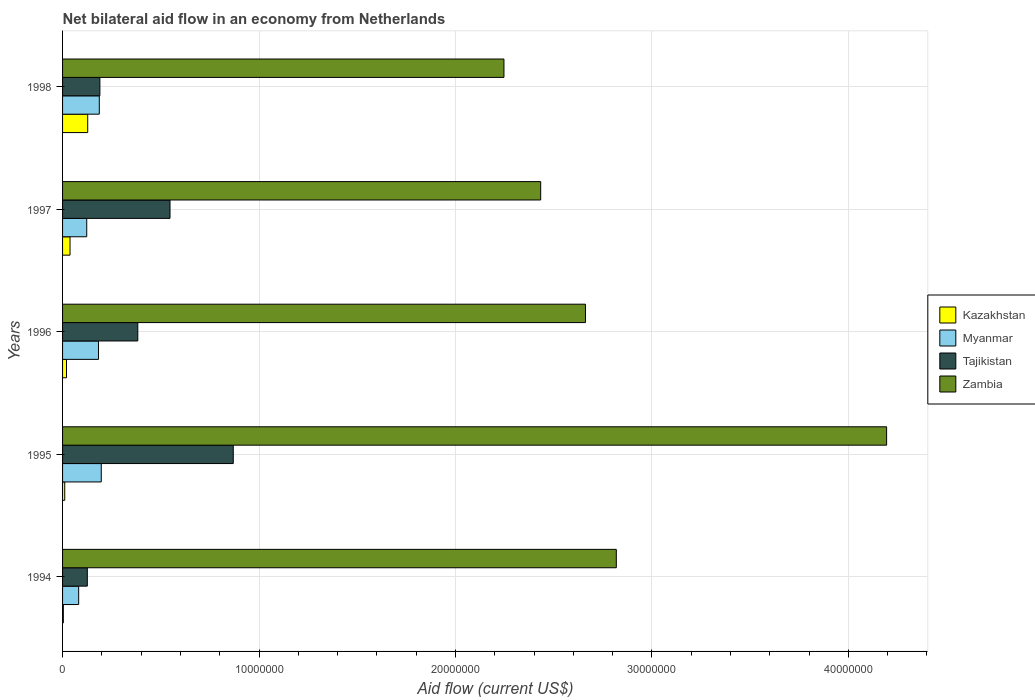How many different coloured bars are there?
Your response must be concise. 4. Are the number of bars on each tick of the Y-axis equal?
Ensure brevity in your answer.  Yes. How many bars are there on the 3rd tick from the top?
Provide a succinct answer. 4. What is the label of the 3rd group of bars from the top?
Your response must be concise. 1996. What is the net bilateral aid flow in Zambia in 1994?
Your response must be concise. 2.82e+07. Across all years, what is the maximum net bilateral aid flow in Myanmar?
Your response must be concise. 1.97e+06. Across all years, what is the minimum net bilateral aid flow in Myanmar?
Your answer should be very brief. 8.20e+05. In which year was the net bilateral aid flow in Myanmar maximum?
Provide a succinct answer. 1995. What is the total net bilateral aid flow in Kazakhstan in the graph?
Provide a short and direct response. 2.01e+06. What is the difference between the net bilateral aid flow in Myanmar in 1996 and that in 1998?
Provide a short and direct response. -4.00e+04. What is the average net bilateral aid flow in Zambia per year?
Your response must be concise. 2.87e+07. In the year 1996, what is the difference between the net bilateral aid flow in Zambia and net bilateral aid flow in Myanmar?
Keep it short and to the point. 2.48e+07. What is the ratio of the net bilateral aid flow in Myanmar in 1994 to that in 1998?
Give a very brief answer. 0.44. Is the net bilateral aid flow in Zambia in 1994 less than that in 1995?
Offer a terse response. Yes. Is the difference between the net bilateral aid flow in Zambia in 1994 and 1998 greater than the difference between the net bilateral aid flow in Myanmar in 1994 and 1998?
Offer a very short reply. Yes. What is the difference between the highest and the second highest net bilateral aid flow in Myanmar?
Provide a succinct answer. 1.00e+05. What is the difference between the highest and the lowest net bilateral aid flow in Myanmar?
Ensure brevity in your answer.  1.15e+06. Is the sum of the net bilateral aid flow in Zambia in 1995 and 1996 greater than the maximum net bilateral aid flow in Kazakhstan across all years?
Offer a terse response. Yes. What does the 3rd bar from the top in 1998 represents?
Ensure brevity in your answer.  Myanmar. What does the 4th bar from the bottom in 1997 represents?
Your answer should be very brief. Zambia. How many years are there in the graph?
Keep it short and to the point. 5. What is the difference between two consecutive major ticks on the X-axis?
Offer a terse response. 1.00e+07. Are the values on the major ticks of X-axis written in scientific E-notation?
Your answer should be compact. No. Does the graph contain grids?
Make the answer very short. Yes. Where does the legend appear in the graph?
Make the answer very short. Center right. How many legend labels are there?
Make the answer very short. 4. How are the legend labels stacked?
Provide a short and direct response. Vertical. What is the title of the graph?
Provide a short and direct response. Net bilateral aid flow in an economy from Netherlands. What is the Aid flow (current US$) in Kazakhstan in 1994?
Your response must be concise. 4.00e+04. What is the Aid flow (current US$) of Myanmar in 1994?
Provide a short and direct response. 8.20e+05. What is the Aid flow (current US$) of Tajikistan in 1994?
Your answer should be very brief. 1.26e+06. What is the Aid flow (current US$) of Zambia in 1994?
Offer a very short reply. 2.82e+07. What is the Aid flow (current US$) of Myanmar in 1995?
Offer a very short reply. 1.97e+06. What is the Aid flow (current US$) in Tajikistan in 1995?
Offer a terse response. 8.69e+06. What is the Aid flow (current US$) of Zambia in 1995?
Make the answer very short. 4.20e+07. What is the Aid flow (current US$) of Myanmar in 1996?
Provide a succinct answer. 1.83e+06. What is the Aid flow (current US$) of Tajikistan in 1996?
Your answer should be very brief. 3.83e+06. What is the Aid flow (current US$) of Zambia in 1996?
Your answer should be very brief. 2.66e+07. What is the Aid flow (current US$) of Myanmar in 1997?
Provide a short and direct response. 1.23e+06. What is the Aid flow (current US$) of Tajikistan in 1997?
Ensure brevity in your answer.  5.47e+06. What is the Aid flow (current US$) in Zambia in 1997?
Offer a very short reply. 2.43e+07. What is the Aid flow (current US$) in Kazakhstan in 1998?
Provide a succinct answer. 1.28e+06. What is the Aid flow (current US$) in Myanmar in 1998?
Give a very brief answer. 1.87e+06. What is the Aid flow (current US$) of Tajikistan in 1998?
Your answer should be compact. 1.90e+06. What is the Aid flow (current US$) of Zambia in 1998?
Make the answer very short. 2.25e+07. Across all years, what is the maximum Aid flow (current US$) of Kazakhstan?
Your answer should be compact. 1.28e+06. Across all years, what is the maximum Aid flow (current US$) in Myanmar?
Offer a terse response. 1.97e+06. Across all years, what is the maximum Aid flow (current US$) of Tajikistan?
Your response must be concise. 8.69e+06. Across all years, what is the maximum Aid flow (current US$) in Zambia?
Offer a very short reply. 4.20e+07. Across all years, what is the minimum Aid flow (current US$) of Myanmar?
Your answer should be compact. 8.20e+05. Across all years, what is the minimum Aid flow (current US$) of Tajikistan?
Offer a terse response. 1.26e+06. Across all years, what is the minimum Aid flow (current US$) in Zambia?
Ensure brevity in your answer.  2.25e+07. What is the total Aid flow (current US$) of Kazakhstan in the graph?
Offer a very short reply. 2.01e+06. What is the total Aid flow (current US$) of Myanmar in the graph?
Make the answer very short. 7.72e+06. What is the total Aid flow (current US$) of Tajikistan in the graph?
Make the answer very short. 2.12e+07. What is the total Aid flow (current US$) of Zambia in the graph?
Offer a terse response. 1.44e+08. What is the difference between the Aid flow (current US$) of Myanmar in 1994 and that in 1995?
Give a very brief answer. -1.15e+06. What is the difference between the Aid flow (current US$) of Tajikistan in 1994 and that in 1995?
Provide a succinct answer. -7.43e+06. What is the difference between the Aid flow (current US$) in Zambia in 1994 and that in 1995?
Provide a succinct answer. -1.38e+07. What is the difference between the Aid flow (current US$) in Kazakhstan in 1994 and that in 1996?
Provide a succinct answer. -1.60e+05. What is the difference between the Aid flow (current US$) in Myanmar in 1994 and that in 1996?
Keep it short and to the point. -1.01e+06. What is the difference between the Aid flow (current US$) of Tajikistan in 1994 and that in 1996?
Offer a terse response. -2.57e+06. What is the difference between the Aid flow (current US$) of Zambia in 1994 and that in 1996?
Your answer should be compact. 1.57e+06. What is the difference between the Aid flow (current US$) of Myanmar in 1994 and that in 1997?
Offer a very short reply. -4.10e+05. What is the difference between the Aid flow (current US$) of Tajikistan in 1994 and that in 1997?
Make the answer very short. -4.21e+06. What is the difference between the Aid flow (current US$) of Zambia in 1994 and that in 1997?
Your answer should be compact. 3.85e+06. What is the difference between the Aid flow (current US$) in Kazakhstan in 1994 and that in 1998?
Offer a very short reply. -1.24e+06. What is the difference between the Aid flow (current US$) in Myanmar in 1994 and that in 1998?
Your answer should be very brief. -1.05e+06. What is the difference between the Aid flow (current US$) in Tajikistan in 1994 and that in 1998?
Ensure brevity in your answer.  -6.40e+05. What is the difference between the Aid flow (current US$) in Zambia in 1994 and that in 1998?
Provide a succinct answer. 5.72e+06. What is the difference between the Aid flow (current US$) of Kazakhstan in 1995 and that in 1996?
Keep it short and to the point. -9.00e+04. What is the difference between the Aid flow (current US$) of Tajikistan in 1995 and that in 1996?
Your answer should be very brief. 4.86e+06. What is the difference between the Aid flow (current US$) in Zambia in 1995 and that in 1996?
Offer a very short reply. 1.53e+07. What is the difference between the Aid flow (current US$) of Myanmar in 1995 and that in 1997?
Offer a very short reply. 7.40e+05. What is the difference between the Aid flow (current US$) in Tajikistan in 1995 and that in 1997?
Offer a very short reply. 3.22e+06. What is the difference between the Aid flow (current US$) of Zambia in 1995 and that in 1997?
Ensure brevity in your answer.  1.76e+07. What is the difference between the Aid flow (current US$) in Kazakhstan in 1995 and that in 1998?
Your answer should be compact. -1.17e+06. What is the difference between the Aid flow (current US$) in Tajikistan in 1995 and that in 1998?
Your answer should be very brief. 6.79e+06. What is the difference between the Aid flow (current US$) of Zambia in 1995 and that in 1998?
Provide a succinct answer. 1.95e+07. What is the difference between the Aid flow (current US$) of Kazakhstan in 1996 and that in 1997?
Your response must be concise. -1.80e+05. What is the difference between the Aid flow (current US$) in Tajikistan in 1996 and that in 1997?
Provide a succinct answer. -1.64e+06. What is the difference between the Aid flow (current US$) of Zambia in 1996 and that in 1997?
Offer a very short reply. 2.28e+06. What is the difference between the Aid flow (current US$) of Kazakhstan in 1996 and that in 1998?
Your answer should be compact. -1.08e+06. What is the difference between the Aid flow (current US$) in Myanmar in 1996 and that in 1998?
Your response must be concise. -4.00e+04. What is the difference between the Aid flow (current US$) in Tajikistan in 1996 and that in 1998?
Provide a succinct answer. 1.93e+06. What is the difference between the Aid flow (current US$) in Zambia in 1996 and that in 1998?
Your response must be concise. 4.15e+06. What is the difference between the Aid flow (current US$) in Kazakhstan in 1997 and that in 1998?
Your response must be concise. -9.00e+05. What is the difference between the Aid flow (current US$) in Myanmar in 1997 and that in 1998?
Give a very brief answer. -6.40e+05. What is the difference between the Aid flow (current US$) in Tajikistan in 1997 and that in 1998?
Your answer should be compact. 3.57e+06. What is the difference between the Aid flow (current US$) in Zambia in 1997 and that in 1998?
Your response must be concise. 1.87e+06. What is the difference between the Aid flow (current US$) in Kazakhstan in 1994 and the Aid flow (current US$) in Myanmar in 1995?
Offer a terse response. -1.93e+06. What is the difference between the Aid flow (current US$) of Kazakhstan in 1994 and the Aid flow (current US$) of Tajikistan in 1995?
Your answer should be compact. -8.65e+06. What is the difference between the Aid flow (current US$) in Kazakhstan in 1994 and the Aid flow (current US$) in Zambia in 1995?
Your answer should be compact. -4.19e+07. What is the difference between the Aid flow (current US$) in Myanmar in 1994 and the Aid flow (current US$) in Tajikistan in 1995?
Give a very brief answer. -7.87e+06. What is the difference between the Aid flow (current US$) of Myanmar in 1994 and the Aid flow (current US$) of Zambia in 1995?
Offer a terse response. -4.11e+07. What is the difference between the Aid flow (current US$) in Tajikistan in 1994 and the Aid flow (current US$) in Zambia in 1995?
Your answer should be very brief. -4.07e+07. What is the difference between the Aid flow (current US$) in Kazakhstan in 1994 and the Aid flow (current US$) in Myanmar in 1996?
Offer a very short reply. -1.79e+06. What is the difference between the Aid flow (current US$) in Kazakhstan in 1994 and the Aid flow (current US$) in Tajikistan in 1996?
Offer a terse response. -3.79e+06. What is the difference between the Aid flow (current US$) in Kazakhstan in 1994 and the Aid flow (current US$) in Zambia in 1996?
Give a very brief answer. -2.66e+07. What is the difference between the Aid flow (current US$) in Myanmar in 1994 and the Aid flow (current US$) in Tajikistan in 1996?
Keep it short and to the point. -3.01e+06. What is the difference between the Aid flow (current US$) in Myanmar in 1994 and the Aid flow (current US$) in Zambia in 1996?
Your answer should be compact. -2.58e+07. What is the difference between the Aid flow (current US$) of Tajikistan in 1994 and the Aid flow (current US$) of Zambia in 1996?
Your response must be concise. -2.54e+07. What is the difference between the Aid flow (current US$) of Kazakhstan in 1994 and the Aid flow (current US$) of Myanmar in 1997?
Keep it short and to the point. -1.19e+06. What is the difference between the Aid flow (current US$) in Kazakhstan in 1994 and the Aid flow (current US$) in Tajikistan in 1997?
Provide a succinct answer. -5.43e+06. What is the difference between the Aid flow (current US$) in Kazakhstan in 1994 and the Aid flow (current US$) in Zambia in 1997?
Provide a succinct answer. -2.43e+07. What is the difference between the Aid flow (current US$) in Myanmar in 1994 and the Aid flow (current US$) in Tajikistan in 1997?
Provide a succinct answer. -4.65e+06. What is the difference between the Aid flow (current US$) of Myanmar in 1994 and the Aid flow (current US$) of Zambia in 1997?
Provide a succinct answer. -2.35e+07. What is the difference between the Aid flow (current US$) in Tajikistan in 1994 and the Aid flow (current US$) in Zambia in 1997?
Provide a short and direct response. -2.31e+07. What is the difference between the Aid flow (current US$) in Kazakhstan in 1994 and the Aid flow (current US$) in Myanmar in 1998?
Your answer should be compact. -1.83e+06. What is the difference between the Aid flow (current US$) in Kazakhstan in 1994 and the Aid flow (current US$) in Tajikistan in 1998?
Provide a short and direct response. -1.86e+06. What is the difference between the Aid flow (current US$) of Kazakhstan in 1994 and the Aid flow (current US$) of Zambia in 1998?
Offer a very short reply. -2.24e+07. What is the difference between the Aid flow (current US$) in Myanmar in 1994 and the Aid flow (current US$) in Tajikistan in 1998?
Provide a succinct answer. -1.08e+06. What is the difference between the Aid flow (current US$) in Myanmar in 1994 and the Aid flow (current US$) in Zambia in 1998?
Offer a very short reply. -2.16e+07. What is the difference between the Aid flow (current US$) in Tajikistan in 1994 and the Aid flow (current US$) in Zambia in 1998?
Give a very brief answer. -2.12e+07. What is the difference between the Aid flow (current US$) in Kazakhstan in 1995 and the Aid flow (current US$) in Myanmar in 1996?
Your answer should be compact. -1.72e+06. What is the difference between the Aid flow (current US$) of Kazakhstan in 1995 and the Aid flow (current US$) of Tajikistan in 1996?
Keep it short and to the point. -3.72e+06. What is the difference between the Aid flow (current US$) of Kazakhstan in 1995 and the Aid flow (current US$) of Zambia in 1996?
Your answer should be compact. -2.65e+07. What is the difference between the Aid flow (current US$) in Myanmar in 1995 and the Aid flow (current US$) in Tajikistan in 1996?
Offer a terse response. -1.86e+06. What is the difference between the Aid flow (current US$) of Myanmar in 1995 and the Aid flow (current US$) of Zambia in 1996?
Keep it short and to the point. -2.46e+07. What is the difference between the Aid flow (current US$) of Tajikistan in 1995 and the Aid flow (current US$) of Zambia in 1996?
Provide a short and direct response. -1.79e+07. What is the difference between the Aid flow (current US$) of Kazakhstan in 1995 and the Aid flow (current US$) of Myanmar in 1997?
Provide a succinct answer. -1.12e+06. What is the difference between the Aid flow (current US$) of Kazakhstan in 1995 and the Aid flow (current US$) of Tajikistan in 1997?
Your answer should be compact. -5.36e+06. What is the difference between the Aid flow (current US$) in Kazakhstan in 1995 and the Aid flow (current US$) in Zambia in 1997?
Your response must be concise. -2.42e+07. What is the difference between the Aid flow (current US$) in Myanmar in 1995 and the Aid flow (current US$) in Tajikistan in 1997?
Keep it short and to the point. -3.50e+06. What is the difference between the Aid flow (current US$) in Myanmar in 1995 and the Aid flow (current US$) in Zambia in 1997?
Provide a short and direct response. -2.24e+07. What is the difference between the Aid flow (current US$) in Tajikistan in 1995 and the Aid flow (current US$) in Zambia in 1997?
Ensure brevity in your answer.  -1.56e+07. What is the difference between the Aid flow (current US$) of Kazakhstan in 1995 and the Aid flow (current US$) of Myanmar in 1998?
Make the answer very short. -1.76e+06. What is the difference between the Aid flow (current US$) in Kazakhstan in 1995 and the Aid flow (current US$) in Tajikistan in 1998?
Offer a very short reply. -1.79e+06. What is the difference between the Aid flow (current US$) of Kazakhstan in 1995 and the Aid flow (current US$) of Zambia in 1998?
Offer a very short reply. -2.24e+07. What is the difference between the Aid flow (current US$) of Myanmar in 1995 and the Aid flow (current US$) of Tajikistan in 1998?
Ensure brevity in your answer.  7.00e+04. What is the difference between the Aid flow (current US$) in Myanmar in 1995 and the Aid flow (current US$) in Zambia in 1998?
Keep it short and to the point. -2.05e+07. What is the difference between the Aid flow (current US$) in Tajikistan in 1995 and the Aid flow (current US$) in Zambia in 1998?
Provide a short and direct response. -1.38e+07. What is the difference between the Aid flow (current US$) of Kazakhstan in 1996 and the Aid flow (current US$) of Myanmar in 1997?
Provide a short and direct response. -1.03e+06. What is the difference between the Aid flow (current US$) in Kazakhstan in 1996 and the Aid flow (current US$) in Tajikistan in 1997?
Give a very brief answer. -5.27e+06. What is the difference between the Aid flow (current US$) of Kazakhstan in 1996 and the Aid flow (current US$) of Zambia in 1997?
Provide a short and direct response. -2.41e+07. What is the difference between the Aid flow (current US$) of Myanmar in 1996 and the Aid flow (current US$) of Tajikistan in 1997?
Your answer should be compact. -3.64e+06. What is the difference between the Aid flow (current US$) in Myanmar in 1996 and the Aid flow (current US$) in Zambia in 1997?
Offer a terse response. -2.25e+07. What is the difference between the Aid flow (current US$) of Tajikistan in 1996 and the Aid flow (current US$) of Zambia in 1997?
Make the answer very short. -2.05e+07. What is the difference between the Aid flow (current US$) of Kazakhstan in 1996 and the Aid flow (current US$) of Myanmar in 1998?
Your answer should be compact. -1.67e+06. What is the difference between the Aid flow (current US$) in Kazakhstan in 1996 and the Aid flow (current US$) in Tajikistan in 1998?
Ensure brevity in your answer.  -1.70e+06. What is the difference between the Aid flow (current US$) of Kazakhstan in 1996 and the Aid flow (current US$) of Zambia in 1998?
Provide a succinct answer. -2.23e+07. What is the difference between the Aid flow (current US$) of Myanmar in 1996 and the Aid flow (current US$) of Tajikistan in 1998?
Your response must be concise. -7.00e+04. What is the difference between the Aid flow (current US$) of Myanmar in 1996 and the Aid flow (current US$) of Zambia in 1998?
Make the answer very short. -2.06e+07. What is the difference between the Aid flow (current US$) of Tajikistan in 1996 and the Aid flow (current US$) of Zambia in 1998?
Provide a succinct answer. -1.86e+07. What is the difference between the Aid flow (current US$) in Kazakhstan in 1997 and the Aid flow (current US$) in Myanmar in 1998?
Offer a very short reply. -1.49e+06. What is the difference between the Aid flow (current US$) of Kazakhstan in 1997 and the Aid flow (current US$) of Tajikistan in 1998?
Ensure brevity in your answer.  -1.52e+06. What is the difference between the Aid flow (current US$) of Kazakhstan in 1997 and the Aid flow (current US$) of Zambia in 1998?
Offer a very short reply. -2.21e+07. What is the difference between the Aid flow (current US$) in Myanmar in 1997 and the Aid flow (current US$) in Tajikistan in 1998?
Make the answer very short. -6.70e+05. What is the difference between the Aid flow (current US$) in Myanmar in 1997 and the Aid flow (current US$) in Zambia in 1998?
Offer a very short reply. -2.12e+07. What is the difference between the Aid flow (current US$) of Tajikistan in 1997 and the Aid flow (current US$) of Zambia in 1998?
Offer a very short reply. -1.70e+07. What is the average Aid flow (current US$) in Kazakhstan per year?
Keep it short and to the point. 4.02e+05. What is the average Aid flow (current US$) in Myanmar per year?
Provide a succinct answer. 1.54e+06. What is the average Aid flow (current US$) in Tajikistan per year?
Offer a terse response. 4.23e+06. What is the average Aid flow (current US$) in Zambia per year?
Your answer should be compact. 2.87e+07. In the year 1994, what is the difference between the Aid flow (current US$) in Kazakhstan and Aid flow (current US$) in Myanmar?
Ensure brevity in your answer.  -7.80e+05. In the year 1994, what is the difference between the Aid flow (current US$) of Kazakhstan and Aid flow (current US$) of Tajikistan?
Ensure brevity in your answer.  -1.22e+06. In the year 1994, what is the difference between the Aid flow (current US$) of Kazakhstan and Aid flow (current US$) of Zambia?
Give a very brief answer. -2.82e+07. In the year 1994, what is the difference between the Aid flow (current US$) in Myanmar and Aid flow (current US$) in Tajikistan?
Your answer should be compact. -4.40e+05. In the year 1994, what is the difference between the Aid flow (current US$) of Myanmar and Aid flow (current US$) of Zambia?
Keep it short and to the point. -2.74e+07. In the year 1994, what is the difference between the Aid flow (current US$) of Tajikistan and Aid flow (current US$) of Zambia?
Ensure brevity in your answer.  -2.69e+07. In the year 1995, what is the difference between the Aid flow (current US$) in Kazakhstan and Aid flow (current US$) in Myanmar?
Your answer should be compact. -1.86e+06. In the year 1995, what is the difference between the Aid flow (current US$) of Kazakhstan and Aid flow (current US$) of Tajikistan?
Offer a very short reply. -8.58e+06. In the year 1995, what is the difference between the Aid flow (current US$) of Kazakhstan and Aid flow (current US$) of Zambia?
Ensure brevity in your answer.  -4.18e+07. In the year 1995, what is the difference between the Aid flow (current US$) in Myanmar and Aid flow (current US$) in Tajikistan?
Provide a short and direct response. -6.72e+06. In the year 1995, what is the difference between the Aid flow (current US$) of Myanmar and Aid flow (current US$) of Zambia?
Your response must be concise. -4.00e+07. In the year 1995, what is the difference between the Aid flow (current US$) of Tajikistan and Aid flow (current US$) of Zambia?
Your answer should be compact. -3.33e+07. In the year 1996, what is the difference between the Aid flow (current US$) in Kazakhstan and Aid flow (current US$) in Myanmar?
Offer a very short reply. -1.63e+06. In the year 1996, what is the difference between the Aid flow (current US$) in Kazakhstan and Aid flow (current US$) in Tajikistan?
Make the answer very short. -3.63e+06. In the year 1996, what is the difference between the Aid flow (current US$) of Kazakhstan and Aid flow (current US$) of Zambia?
Keep it short and to the point. -2.64e+07. In the year 1996, what is the difference between the Aid flow (current US$) in Myanmar and Aid flow (current US$) in Zambia?
Ensure brevity in your answer.  -2.48e+07. In the year 1996, what is the difference between the Aid flow (current US$) in Tajikistan and Aid flow (current US$) in Zambia?
Give a very brief answer. -2.28e+07. In the year 1997, what is the difference between the Aid flow (current US$) of Kazakhstan and Aid flow (current US$) of Myanmar?
Your response must be concise. -8.50e+05. In the year 1997, what is the difference between the Aid flow (current US$) in Kazakhstan and Aid flow (current US$) in Tajikistan?
Offer a terse response. -5.09e+06. In the year 1997, what is the difference between the Aid flow (current US$) of Kazakhstan and Aid flow (current US$) of Zambia?
Your answer should be compact. -2.40e+07. In the year 1997, what is the difference between the Aid flow (current US$) in Myanmar and Aid flow (current US$) in Tajikistan?
Keep it short and to the point. -4.24e+06. In the year 1997, what is the difference between the Aid flow (current US$) of Myanmar and Aid flow (current US$) of Zambia?
Offer a terse response. -2.31e+07. In the year 1997, what is the difference between the Aid flow (current US$) in Tajikistan and Aid flow (current US$) in Zambia?
Keep it short and to the point. -1.89e+07. In the year 1998, what is the difference between the Aid flow (current US$) in Kazakhstan and Aid flow (current US$) in Myanmar?
Offer a very short reply. -5.90e+05. In the year 1998, what is the difference between the Aid flow (current US$) of Kazakhstan and Aid flow (current US$) of Tajikistan?
Provide a short and direct response. -6.20e+05. In the year 1998, what is the difference between the Aid flow (current US$) in Kazakhstan and Aid flow (current US$) in Zambia?
Offer a terse response. -2.12e+07. In the year 1998, what is the difference between the Aid flow (current US$) in Myanmar and Aid flow (current US$) in Tajikistan?
Your answer should be compact. -3.00e+04. In the year 1998, what is the difference between the Aid flow (current US$) of Myanmar and Aid flow (current US$) of Zambia?
Offer a very short reply. -2.06e+07. In the year 1998, what is the difference between the Aid flow (current US$) of Tajikistan and Aid flow (current US$) of Zambia?
Provide a short and direct response. -2.06e+07. What is the ratio of the Aid flow (current US$) in Kazakhstan in 1994 to that in 1995?
Offer a very short reply. 0.36. What is the ratio of the Aid flow (current US$) in Myanmar in 1994 to that in 1995?
Ensure brevity in your answer.  0.42. What is the ratio of the Aid flow (current US$) of Tajikistan in 1994 to that in 1995?
Your answer should be very brief. 0.14. What is the ratio of the Aid flow (current US$) of Zambia in 1994 to that in 1995?
Your answer should be compact. 0.67. What is the ratio of the Aid flow (current US$) of Myanmar in 1994 to that in 1996?
Make the answer very short. 0.45. What is the ratio of the Aid flow (current US$) in Tajikistan in 1994 to that in 1996?
Your answer should be compact. 0.33. What is the ratio of the Aid flow (current US$) in Zambia in 1994 to that in 1996?
Provide a short and direct response. 1.06. What is the ratio of the Aid flow (current US$) in Kazakhstan in 1994 to that in 1997?
Provide a succinct answer. 0.11. What is the ratio of the Aid flow (current US$) in Tajikistan in 1994 to that in 1997?
Ensure brevity in your answer.  0.23. What is the ratio of the Aid flow (current US$) of Zambia in 1994 to that in 1997?
Your answer should be very brief. 1.16. What is the ratio of the Aid flow (current US$) of Kazakhstan in 1994 to that in 1998?
Make the answer very short. 0.03. What is the ratio of the Aid flow (current US$) in Myanmar in 1994 to that in 1998?
Offer a terse response. 0.44. What is the ratio of the Aid flow (current US$) of Tajikistan in 1994 to that in 1998?
Give a very brief answer. 0.66. What is the ratio of the Aid flow (current US$) of Zambia in 1994 to that in 1998?
Ensure brevity in your answer.  1.25. What is the ratio of the Aid flow (current US$) of Kazakhstan in 1995 to that in 1996?
Your answer should be compact. 0.55. What is the ratio of the Aid flow (current US$) in Myanmar in 1995 to that in 1996?
Offer a terse response. 1.08. What is the ratio of the Aid flow (current US$) in Tajikistan in 1995 to that in 1996?
Your answer should be very brief. 2.27. What is the ratio of the Aid flow (current US$) in Zambia in 1995 to that in 1996?
Offer a very short reply. 1.58. What is the ratio of the Aid flow (current US$) in Kazakhstan in 1995 to that in 1997?
Offer a very short reply. 0.29. What is the ratio of the Aid flow (current US$) of Myanmar in 1995 to that in 1997?
Offer a terse response. 1.6. What is the ratio of the Aid flow (current US$) in Tajikistan in 1995 to that in 1997?
Provide a short and direct response. 1.59. What is the ratio of the Aid flow (current US$) of Zambia in 1995 to that in 1997?
Provide a succinct answer. 1.72. What is the ratio of the Aid flow (current US$) of Kazakhstan in 1995 to that in 1998?
Your answer should be compact. 0.09. What is the ratio of the Aid flow (current US$) of Myanmar in 1995 to that in 1998?
Make the answer very short. 1.05. What is the ratio of the Aid flow (current US$) in Tajikistan in 1995 to that in 1998?
Keep it short and to the point. 4.57. What is the ratio of the Aid flow (current US$) of Zambia in 1995 to that in 1998?
Your answer should be very brief. 1.87. What is the ratio of the Aid flow (current US$) in Kazakhstan in 1996 to that in 1997?
Your response must be concise. 0.53. What is the ratio of the Aid flow (current US$) in Myanmar in 1996 to that in 1997?
Keep it short and to the point. 1.49. What is the ratio of the Aid flow (current US$) of Tajikistan in 1996 to that in 1997?
Your answer should be very brief. 0.7. What is the ratio of the Aid flow (current US$) of Zambia in 1996 to that in 1997?
Offer a very short reply. 1.09. What is the ratio of the Aid flow (current US$) of Kazakhstan in 1996 to that in 1998?
Ensure brevity in your answer.  0.16. What is the ratio of the Aid flow (current US$) in Myanmar in 1996 to that in 1998?
Offer a very short reply. 0.98. What is the ratio of the Aid flow (current US$) in Tajikistan in 1996 to that in 1998?
Provide a succinct answer. 2.02. What is the ratio of the Aid flow (current US$) of Zambia in 1996 to that in 1998?
Ensure brevity in your answer.  1.18. What is the ratio of the Aid flow (current US$) of Kazakhstan in 1997 to that in 1998?
Your answer should be compact. 0.3. What is the ratio of the Aid flow (current US$) of Myanmar in 1997 to that in 1998?
Your answer should be very brief. 0.66. What is the ratio of the Aid flow (current US$) of Tajikistan in 1997 to that in 1998?
Give a very brief answer. 2.88. What is the ratio of the Aid flow (current US$) in Zambia in 1997 to that in 1998?
Make the answer very short. 1.08. What is the difference between the highest and the second highest Aid flow (current US$) of Tajikistan?
Your answer should be compact. 3.22e+06. What is the difference between the highest and the second highest Aid flow (current US$) in Zambia?
Give a very brief answer. 1.38e+07. What is the difference between the highest and the lowest Aid flow (current US$) of Kazakhstan?
Provide a short and direct response. 1.24e+06. What is the difference between the highest and the lowest Aid flow (current US$) in Myanmar?
Provide a succinct answer. 1.15e+06. What is the difference between the highest and the lowest Aid flow (current US$) of Tajikistan?
Give a very brief answer. 7.43e+06. What is the difference between the highest and the lowest Aid flow (current US$) in Zambia?
Make the answer very short. 1.95e+07. 